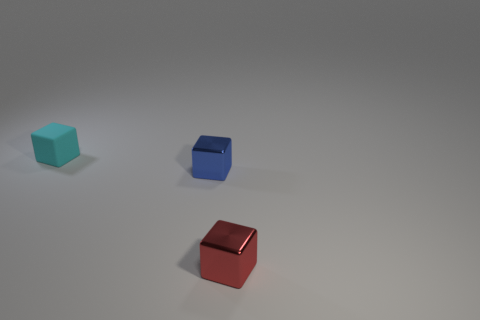There is another thing that is made of the same material as the tiny red thing; what is its color? blue 